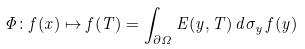<formula> <loc_0><loc_0><loc_500><loc_500>\Phi \colon f ( x ) \mapsto f ( T ) = \int _ { \partial \Omega } E ( y , T ) \, d \sigma _ { y } \, f ( y )</formula> 